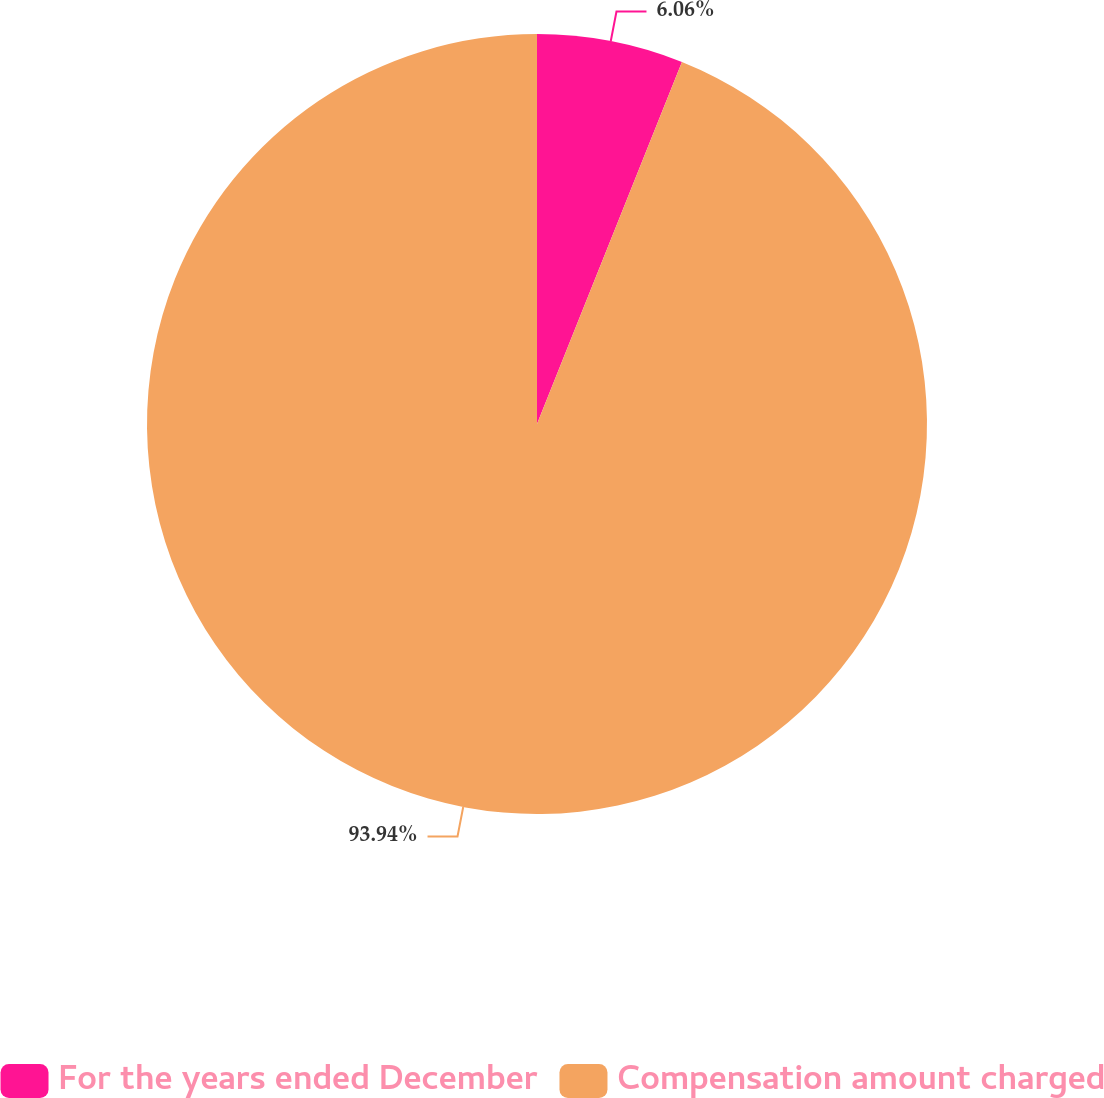Convert chart to OTSL. <chart><loc_0><loc_0><loc_500><loc_500><pie_chart><fcel>For the years ended December<fcel>Compensation amount charged<nl><fcel>6.06%<fcel>93.94%<nl></chart> 